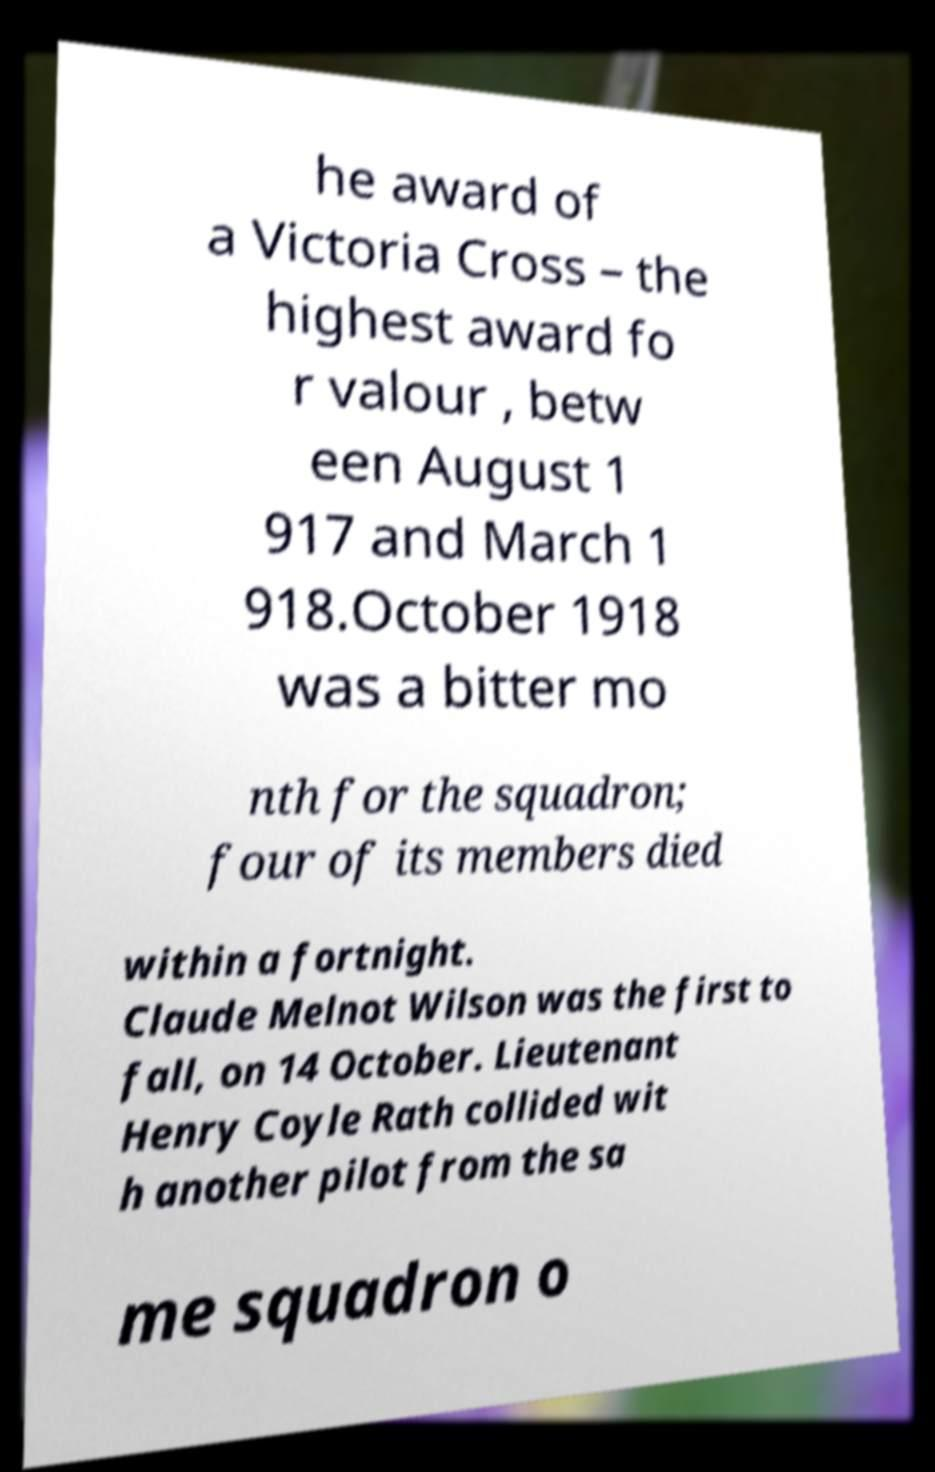I need the written content from this picture converted into text. Can you do that? he award of a Victoria Cross – the highest award fo r valour , betw een August 1 917 and March 1 918.October 1918 was a bitter mo nth for the squadron; four of its members died within a fortnight. Claude Melnot Wilson was the first to fall, on 14 October. Lieutenant Henry Coyle Rath collided wit h another pilot from the sa me squadron o 